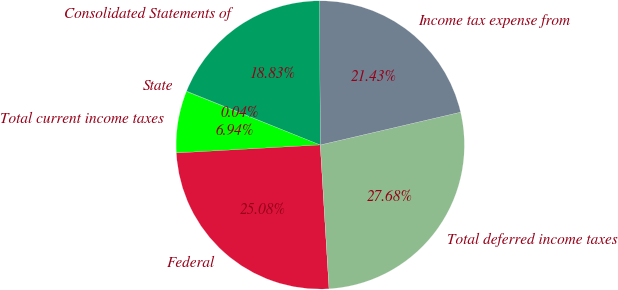Convert chart. <chart><loc_0><loc_0><loc_500><loc_500><pie_chart><fcel>State<fcel>Total current income taxes<fcel>Federal<fcel>Total deferred income taxes<fcel>Income tax expense from<fcel>Consolidated Statements of<nl><fcel>0.04%<fcel>6.94%<fcel>25.08%<fcel>27.68%<fcel>21.43%<fcel>18.83%<nl></chart> 